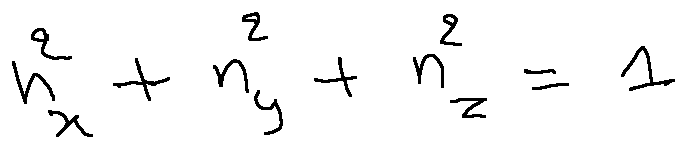Convert formula to latex. <formula><loc_0><loc_0><loc_500><loc_500>n _ { x } ^ { 2 } + n _ { y } ^ { 2 } + n _ { z } ^ { 2 } = 1</formula> 